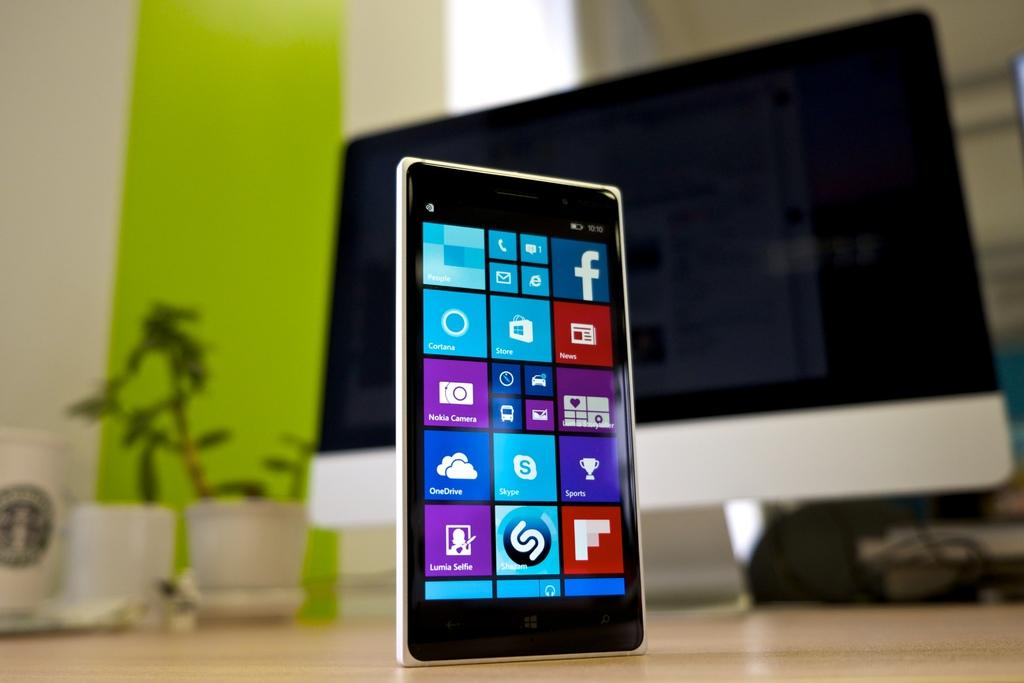What object is located in the foreground of the image? There is a cell phone in the foreground of the image. What other electronic device can be seen in the image? There is a monitor visible in the image, but it is blurry. What type of rainstorm can be seen in the image? There is no rainstorm present in the image; it only features a cell phone and a blurry monitor. 